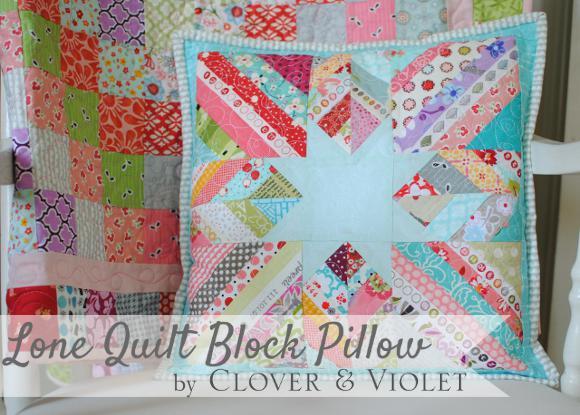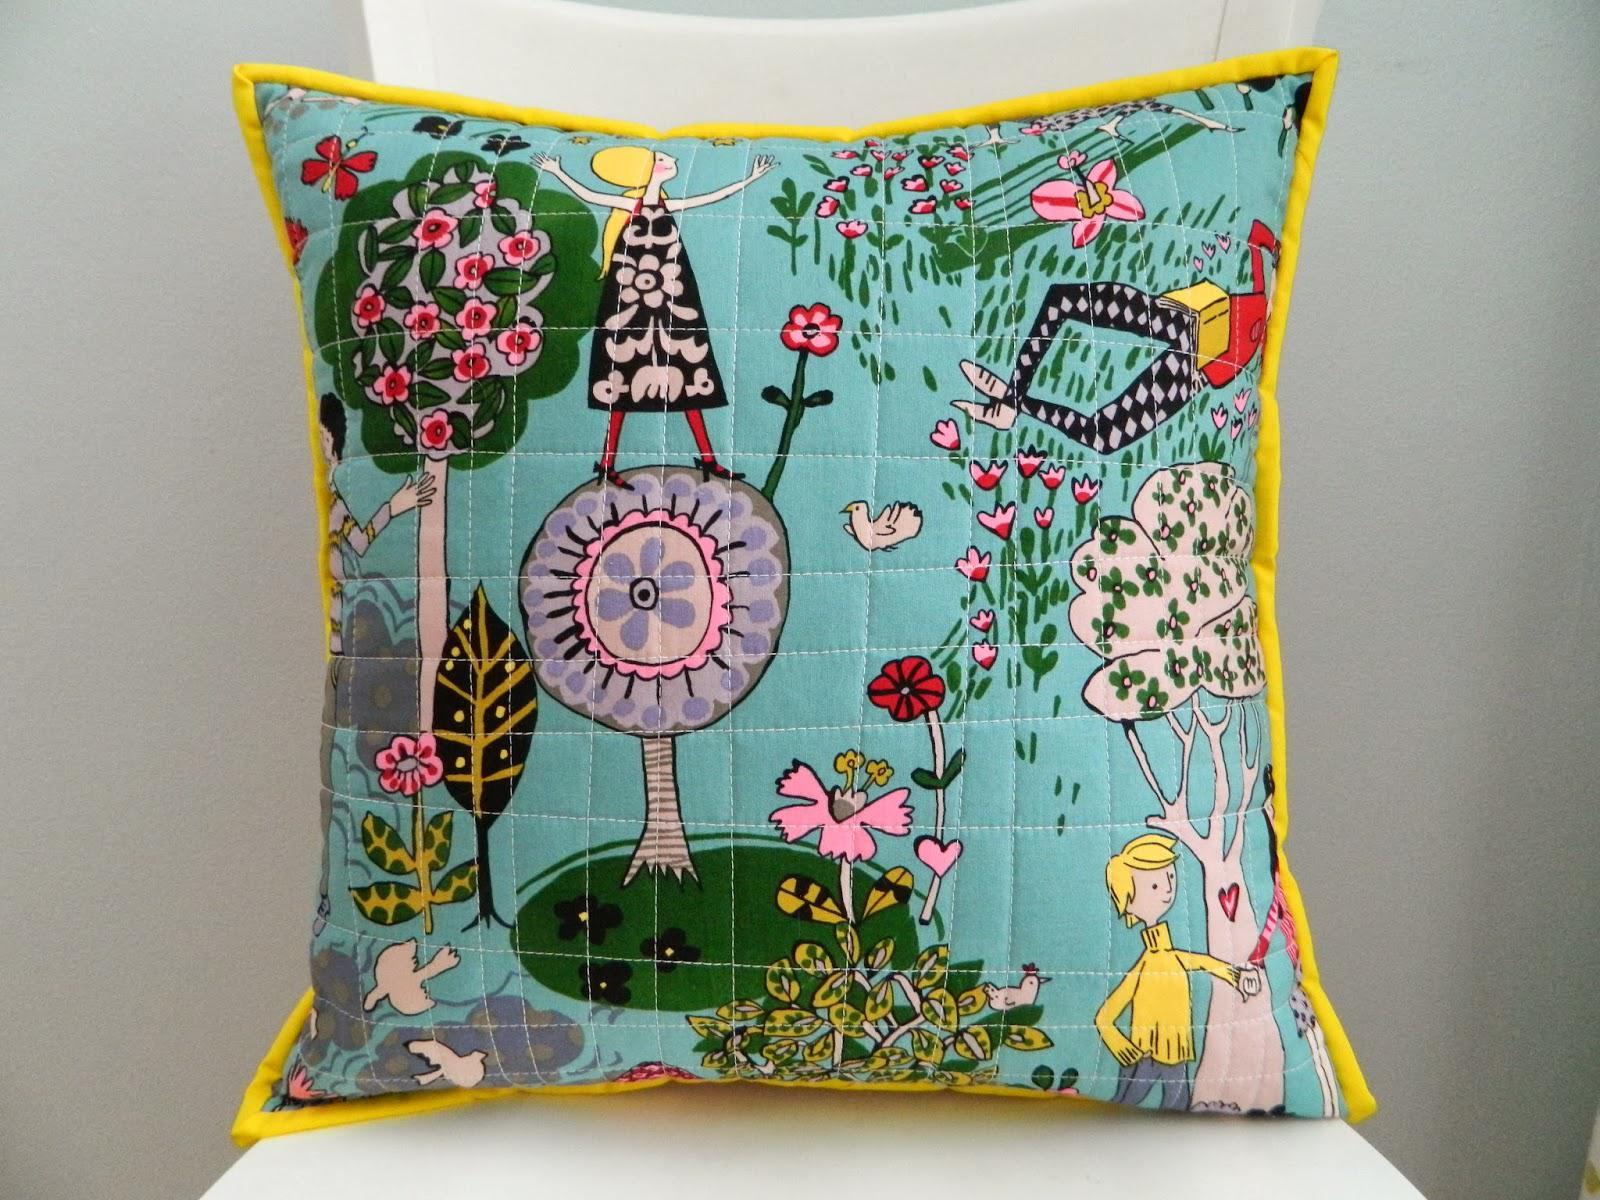The first image is the image on the left, the second image is the image on the right. Analyze the images presented: Is the assertion "One pillow has a vertical stripe pattern." valid? Answer yes or no. No. The first image is the image on the left, the second image is the image on the right. Evaluate the accuracy of this statement regarding the images: "The left and right image contains the same number of quilted piece of fabric.". Is it true? Answer yes or no. No. 